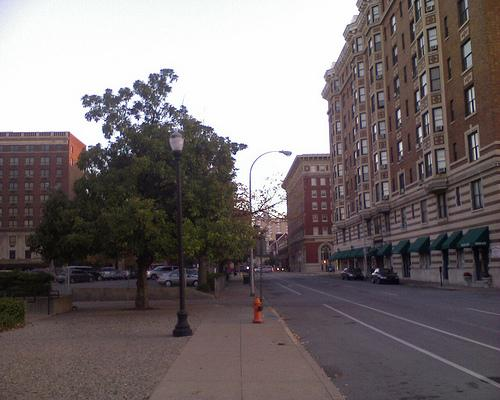List out the things that can be seen on the sidewalk. A red fire hydrant, a street light and pole, a tree, a parking meter, a cement planter, and a lamp post. Describe the overall setting of the image in few words. A peaceful city street with buildings, parked cars, various streetlights, and a large tree. Point out the most striking aspect of the image. The bold green awnings on a red brick building and the red fire hydrant on the sidewalk stand out in the scene. Write a sentence describing the overall atmosphere of the image. The image showcases a calm city street with parked cars, green awnings on a building, and a tree providing shade. Narrate the scene depicted in the image focusing on the surroundings. A serene city street features green awnings on a tall building, parked cars, a large tree, and a red fire hydrant on the sidewalk. What are some prominent objects and their colors in the picture? A red fire hydrant, green awnings on a building, black and silver parked cars, and a large green tree. Briefly state the key features observed in the picture. A quiet street scene with a red fire hydrant, parked cars, a large tree, and green awnings on a building. Mention the general color palette observed in the image. Red, green, silver, black, and gray are the predominant colors in the scene. Mention the most eye-catching details in the picture. A red fire hydrant on the sidewalk, green awnings on a red brick building, and two cars parallel parked on the street. Provide a brief description of the primary elements in the image. A street with parked cars, a red fire hydrant, green awnings on a building, a large tree, and various street lights and poles. 